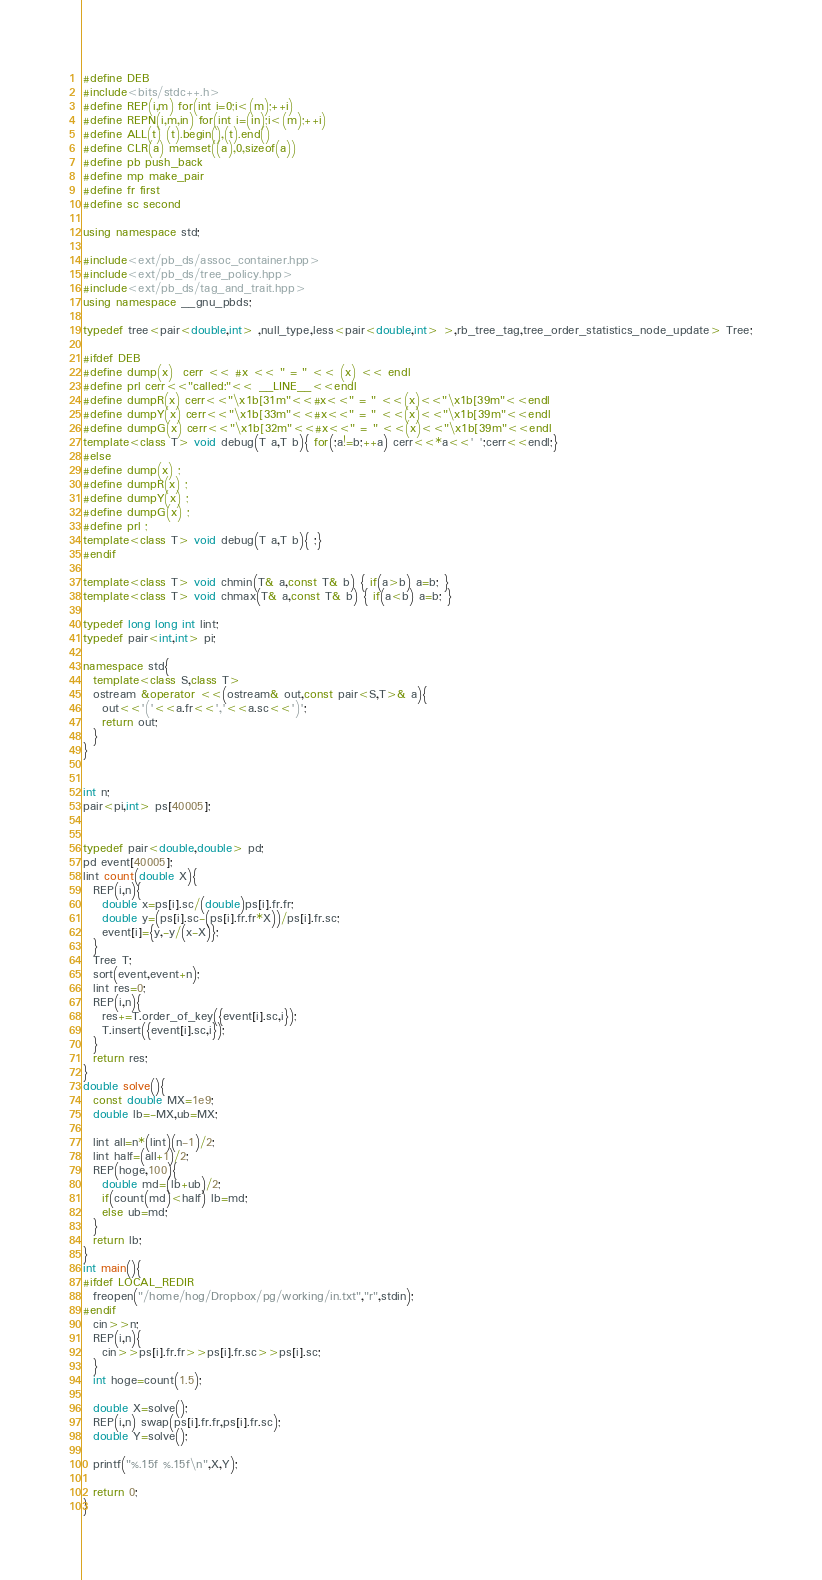Convert code to text. <code><loc_0><loc_0><loc_500><loc_500><_C++_>#define DEB
#include<bits/stdc++.h>
#define REP(i,m) for(int i=0;i<(m);++i)
#define REPN(i,m,in) for(int i=(in);i<(m);++i)
#define ALL(t) (t).begin(),(t).end()
#define CLR(a) memset((a),0,sizeof(a))
#define pb push_back
#define mp make_pair
#define fr first
#define sc second

using namespace std;

#include<ext/pb_ds/assoc_container.hpp>
#include<ext/pb_ds/tree_policy.hpp>
#include<ext/pb_ds/tag_and_trait.hpp>
using namespace __gnu_pbds;

typedef tree<pair<double,int> ,null_type,less<pair<double,int> >,rb_tree_tag,tree_order_statistics_node_update> Tree;

#ifdef DEB
#define dump(x)  cerr << #x << " = " << (x) << endl
#define prl cerr<<"called:"<< __LINE__<<endl
#define dumpR(x) cerr<<"\x1b[31m"<<#x<<" = " <<(x)<<"\x1b[39m"<<endl
#define dumpY(x) cerr<<"\x1b[33m"<<#x<<" = " <<(x)<<"\x1b[39m"<<endl
#define dumpG(x) cerr<<"\x1b[32m"<<#x<<" = " <<(x)<<"\x1b[39m"<<endl
template<class T> void debug(T a,T b){ for(;a!=b;++a) cerr<<*a<<' ';cerr<<endl;}
#else
#define dump(x) ;
#define dumpR(x) ;
#define dumpY(x) ;
#define dumpG(x) ;
#define prl ;
template<class T> void debug(T a,T b){ ;}
#endif

template<class T> void chmin(T& a,const T& b) { if(a>b) a=b; }
template<class T> void chmax(T& a,const T& b) { if(a<b) a=b; }

typedef long long int lint;
typedef pair<int,int> pi;

namespace std{
  template<class S,class T>
  ostream &operator <<(ostream& out,const pair<S,T>& a){
    out<<'('<<a.fr<<','<<a.sc<<')';
    return out;
  }
}


int n;
pair<pi,int> ps[40005];


typedef pair<double,double> pd;
pd event[40005];
lint count(double X){
  REP(i,n){
    double x=ps[i].sc/(double)ps[i].fr.fr;
    double y=(ps[i].sc-(ps[i].fr.fr*X))/ps[i].fr.sc;
    event[i]={y,-y/(x-X)};
  }
  Tree T;
  sort(event,event+n);
  lint res=0;
  REP(i,n){
    res+=T.order_of_key({event[i].sc,i});
    T.insert({event[i].sc,i});
  }
  return res;
}
double solve(){
  const double MX=1e9;
  double lb=-MX,ub=MX;

  lint all=n*(lint)(n-1)/2;
  lint half=(all+1)/2;
  REP(hoge,100){
    double md=(lb+ub)/2;
    if(count(md)<half) lb=md;
    else ub=md;
  }
  return lb;
}
int main(){
#ifdef LOCAL_REDIR
  freopen("/home/hog/Dropbox/pg/working/in.txt","r",stdin);
#endif
  cin>>n;
  REP(i,n){
    cin>>ps[i].fr.fr>>ps[i].fr.sc>>ps[i].sc;
  }
  int hoge=count(1.5);

  double X=solve();
  REP(i,n) swap(ps[i].fr.fr,ps[i].fr.sc);
  double Y=solve();

  printf("%.15f %.15f\n",X,Y);

  return 0;
}




</code> 